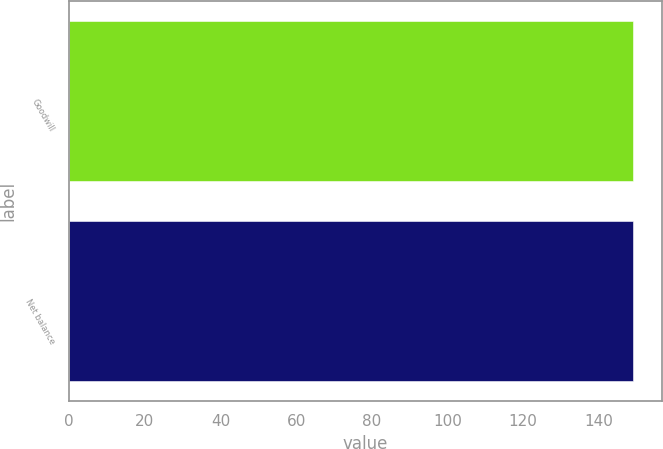Convert chart to OTSL. <chart><loc_0><loc_0><loc_500><loc_500><bar_chart><fcel>Goodwill<fcel>Net balance<nl><fcel>149<fcel>149.1<nl></chart> 